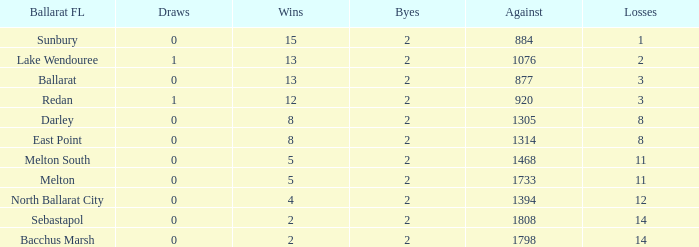How many Byes have Against of 1076 and Wins smaller than 13? None. 